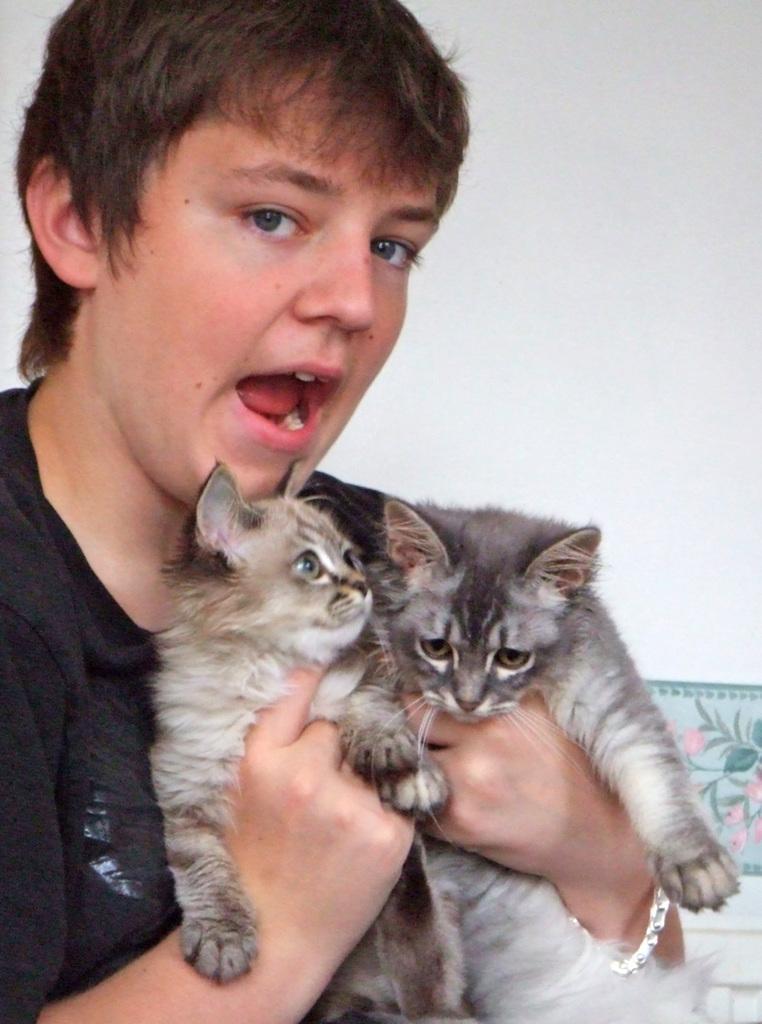In one or two sentences, can you explain what this image depicts? In this image I can see a person wearing black color dress is holding two cats which are black, cream and brown in color. In the background I can see the white colored wall. 